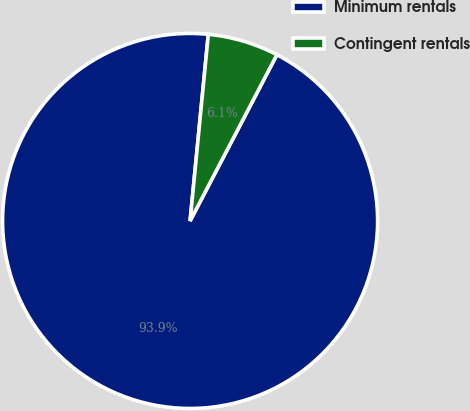Convert chart. <chart><loc_0><loc_0><loc_500><loc_500><pie_chart><fcel>Minimum rentals<fcel>Contingent rentals<nl><fcel>93.89%<fcel>6.11%<nl></chart> 